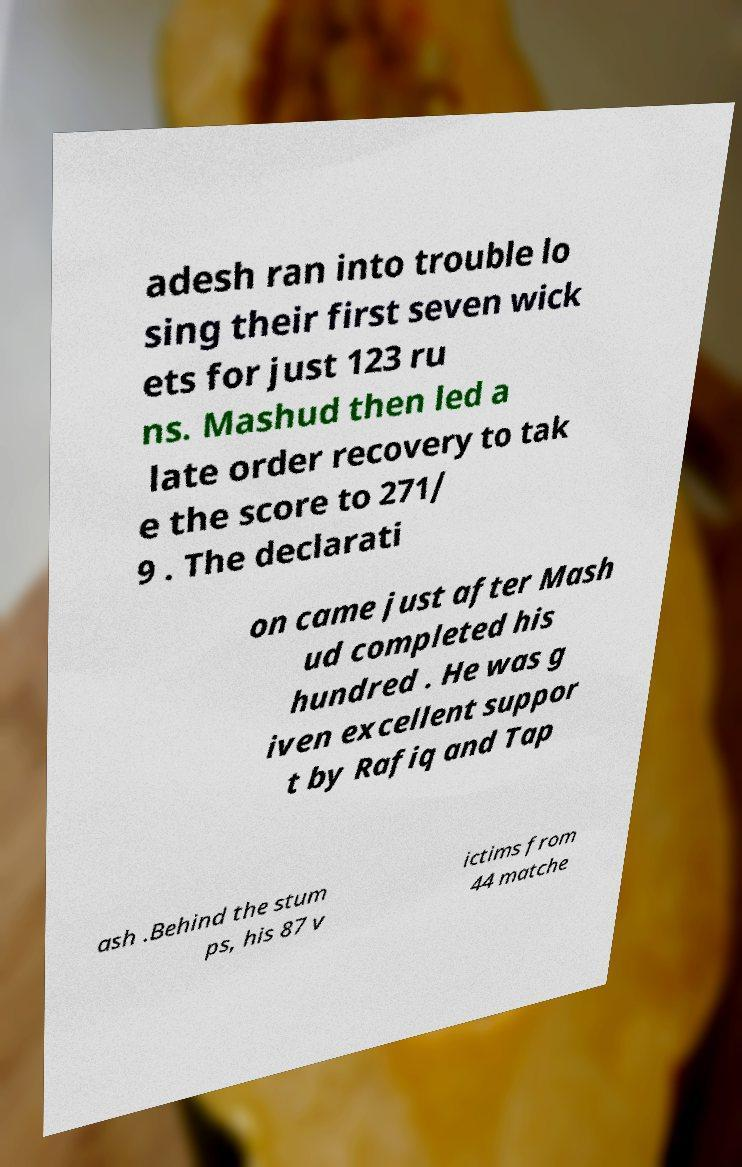There's text embedded in this image that I need extracted. Can you transcribe it verbatim? adesh ran into trouble lo sing their first seven wick ets for just 123 ru ns. Mashud then led a late order recovery to tak e the score to 271/ 9 . The declarati on came just after Mash ud completed his hundred . He was g iven excellent suppor t by Rafiq and Tap ash .Behind the stum ps, his 87 v ictims from 44 matche 